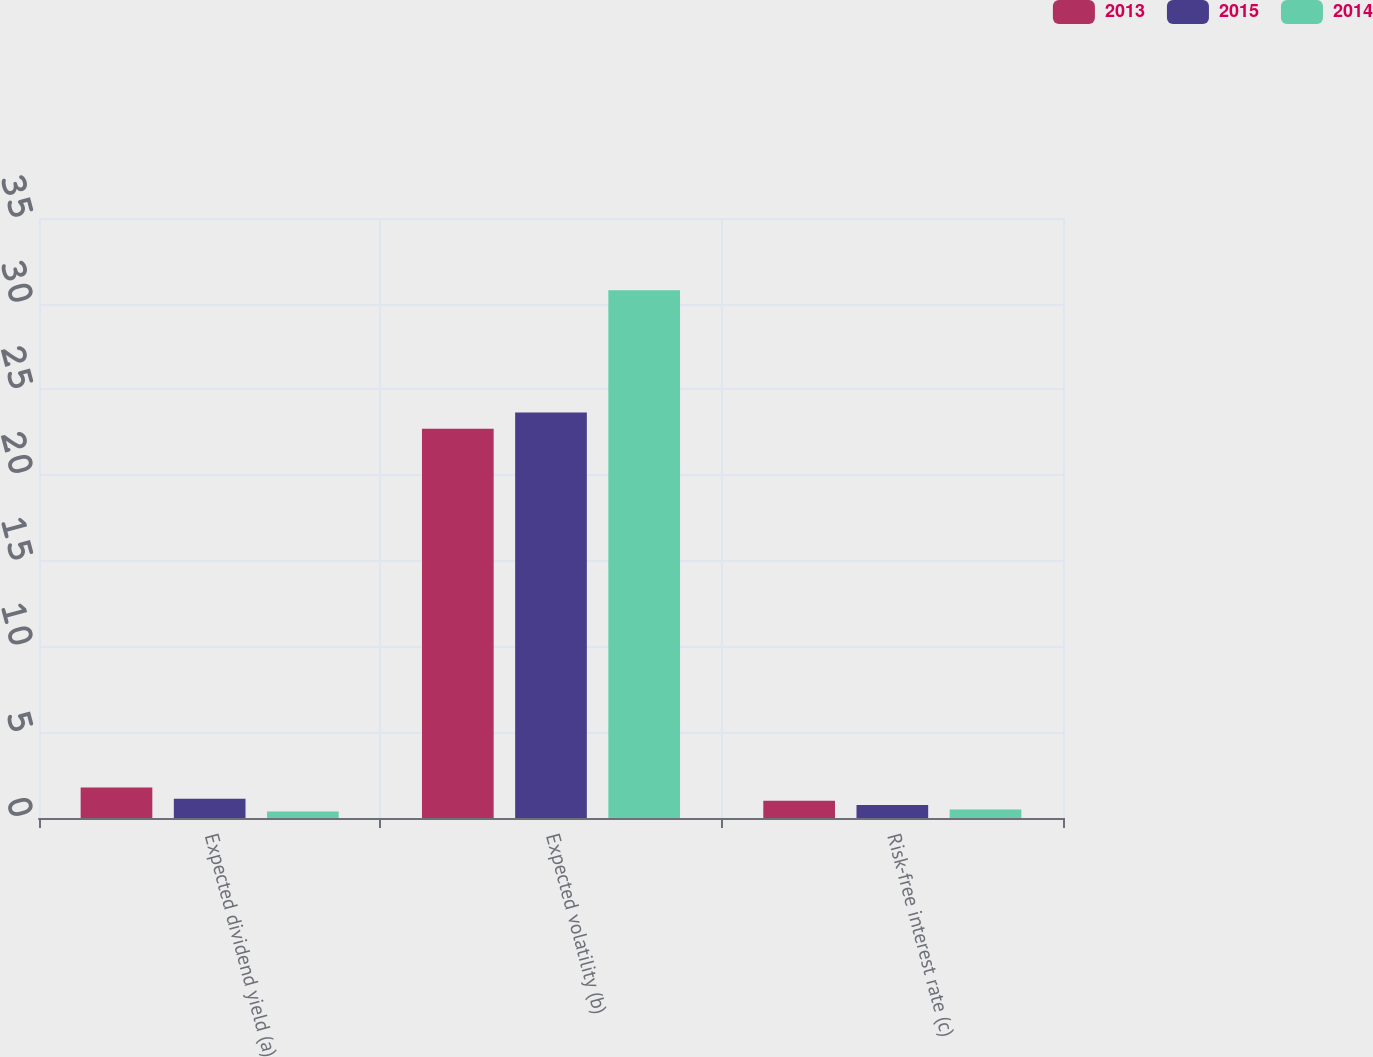Convert chart to OTSL. <chart><loc_0><loc_0><loc_500><loc_500><stacked_bar_chart><ecel><fcel>Expected dividend yield (a)<fcel>Expected volatility (b)<fcel>Risk-free interest rate (c)<nl><fcel>2013<fcel>1.78<fcel>22.71<fcel>1.01<nl><fcel>2015<fcel>1.13<fcel>23.66<fcel>0.76<nl><fcel>2014<fcel>0.38<fcel>30.79<fcel>0.5<nl></chart> 